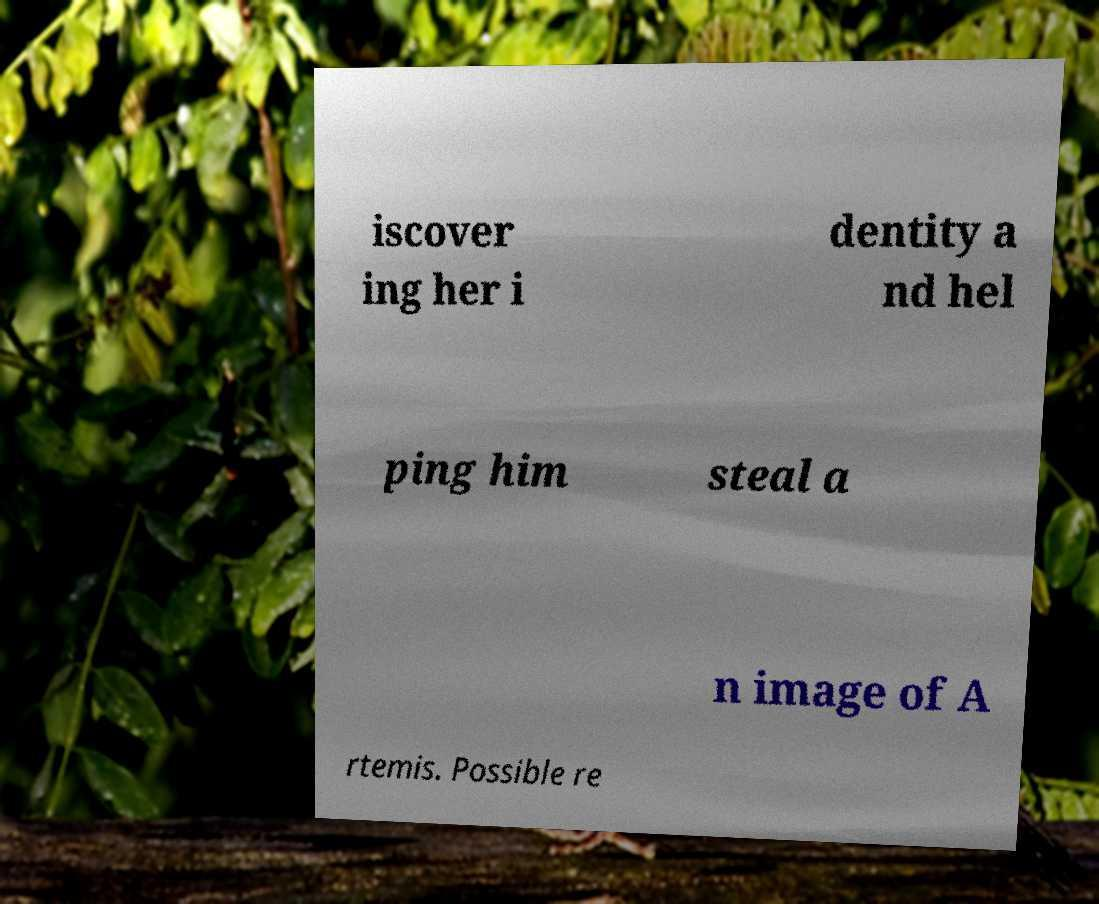Could you extract and type out the text from this image? iscover ing her i dentity a nd hel ping him steal a n image of A rtemis. Possible re 